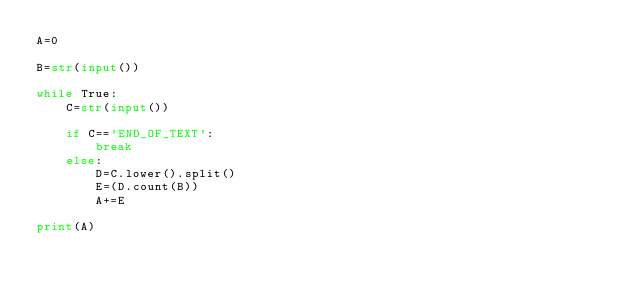<code> <loc_0><loc_0><loc_500><loc_500><_Python_>A=0

B=str(input())

while True:
    C=str(input())
    
    if C=='END_OF_TEXT':
        break
    else:
        D=C.lower().split()
        E=(D.count(B))
        A+=E
        
print(A)
</code> 